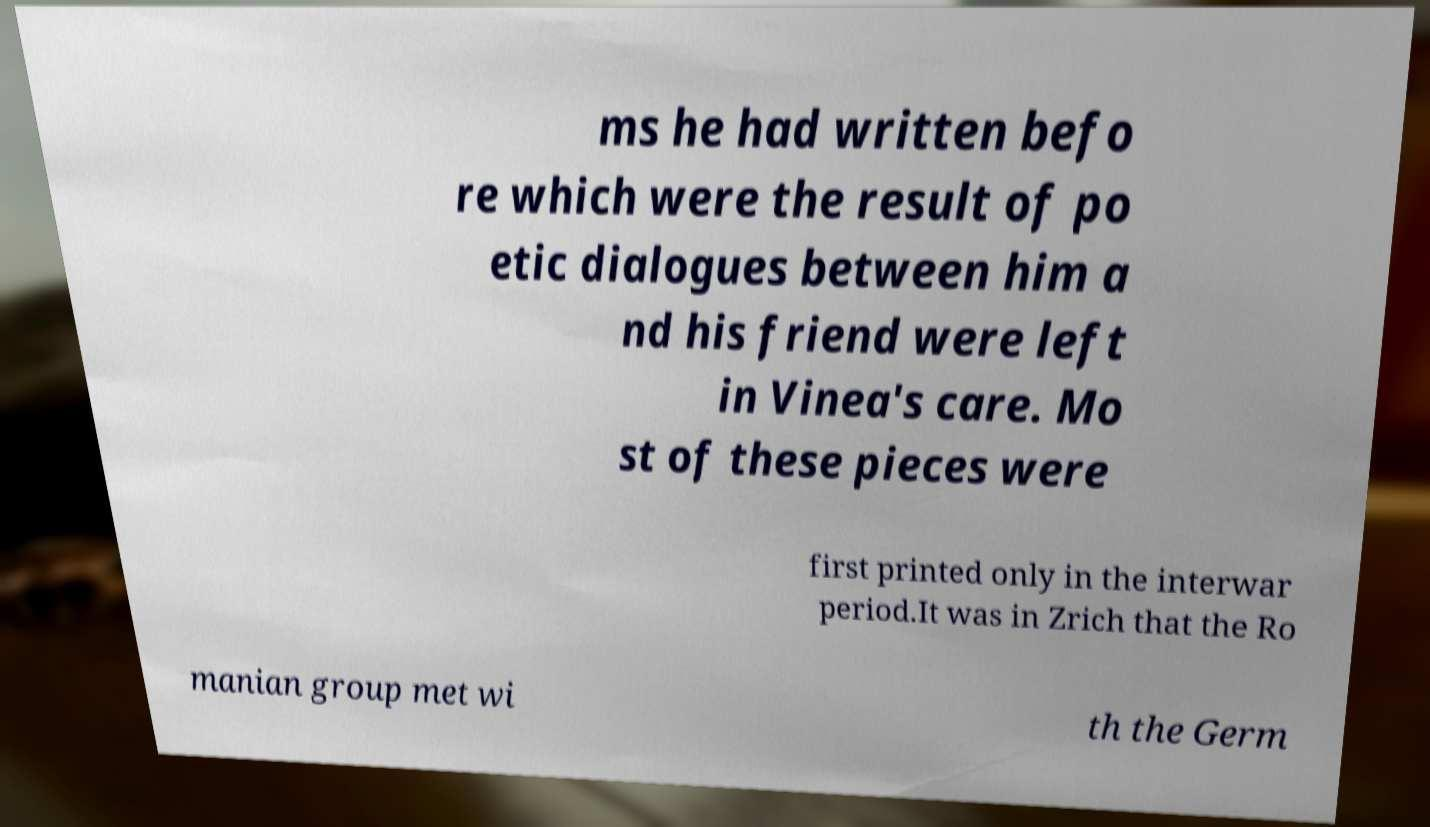What messages or text are displayed in this image? I need them in a readable, typed format. ms he had written befo re which were the result of po etic dialogues between him a nd his friend were left in Vinea's care. Mo st of these pieces were first printed only in the interwar period.It was in Zrich that the Ro manian group met wi th the Germ 